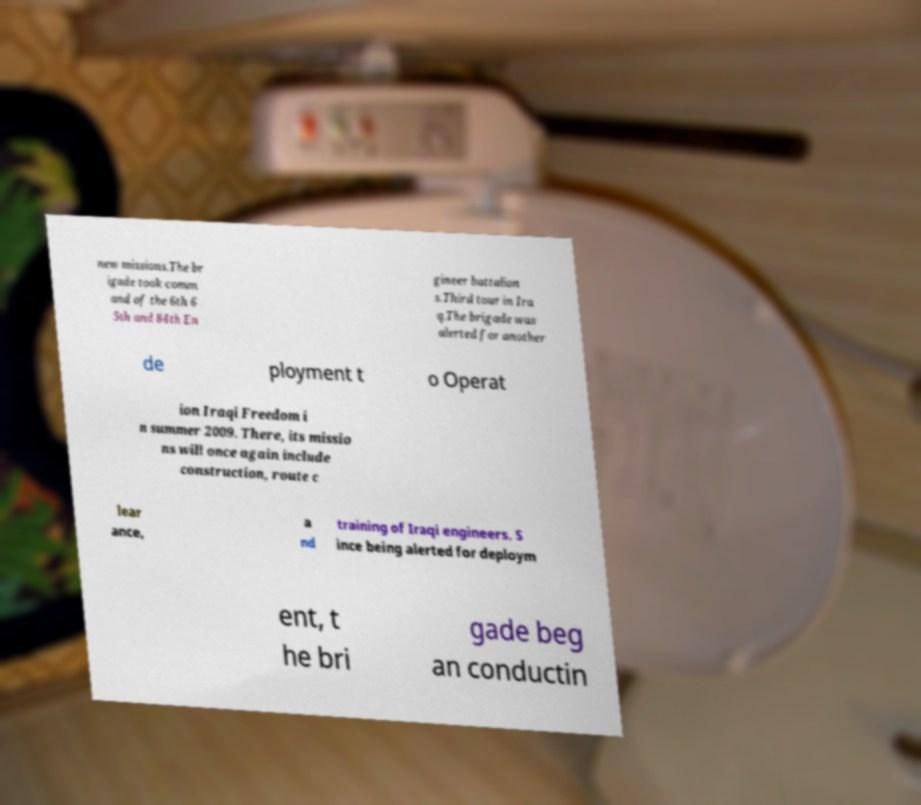There's text embedded in this image that I need extracted. Can you transcribe it verbatim? new missions.The br igade took comm and of the 6th 6 5th and 84th En gineer battalion s.Third tour in Ira q.The brigade was alerted for another de ployment t o Operat ion Iraqi Freedom i n summer 2009. There, its missio ns will once again include construction, route c lear ance, a nd training of Iraqi engineers. S ince being alerted for deploym ent, t he bri gade beg an conductin 